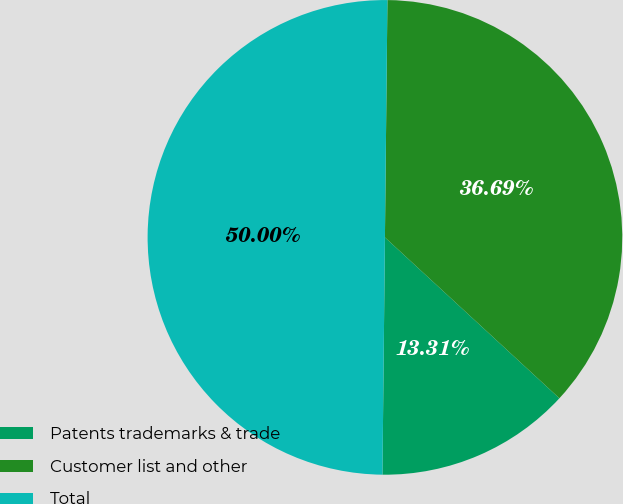Convert chart. <chart><loc_0><loc_0><loc_500><loc_500><pie_chart><fcel>Patents trademarks & trade<fcel>Customer list and other<fcel>Total<nl><fcel>13.31%<fcel>36.69%<fcel>50.0%<nl></chart> 